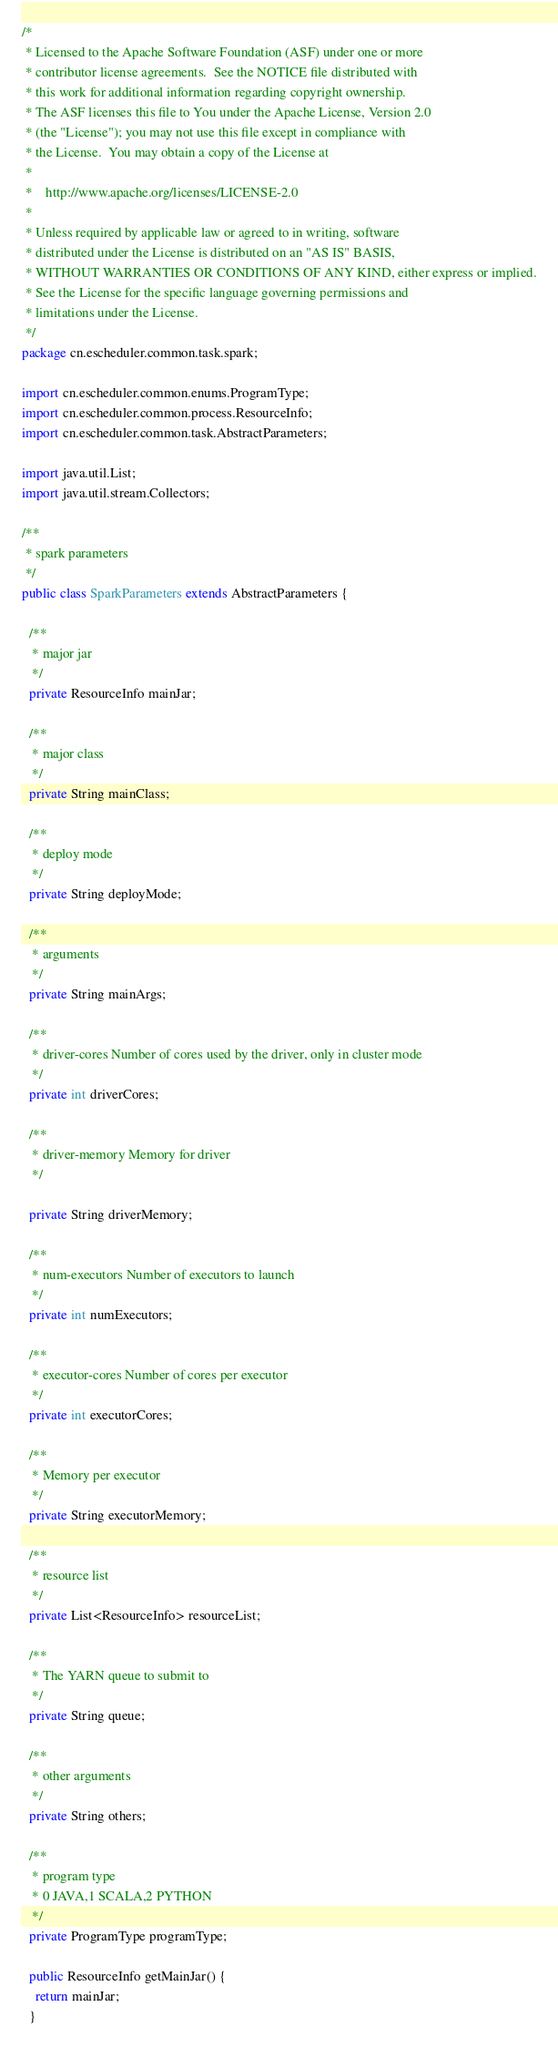Convert code to text. <code><loc_0><loc_0><loc_500><loc_500><_Java_>/*
 * Licensed to the Apache Software Foundation (ASF) under one or more
 * contributor license agreements.  See the NOTICE file distributed with
 * this work for additional information regarding copyright ownership.
 * The ASF licenses this file to You under the Apache License, Version 2.0
 * (the "License"); you may not use this file except in compliance with
 * the License.  You may obtain a copy of the License at
 *
 *    http://www.apache.org/licenses/LICENSE-2.0
 *
 * Unless required by applicable law or agreed to in writing, software
 * distributed under the License is distributed on an "AS IS" BASIS,
 * WITHOUT WARRANTIES OR CONDITIONS OF ANY KIND, either express or implied.
 * See the License for the specific language governing permissions and
 * limitations under the License.
 */
package cn.escheduler.common.task.spark;

import cn.escheduler.common.enums.ProgramType;
import cn.escheduler.common.process.ResourceInfo;
import cn.escheduler.common.task.AbstractParameters;

import java.util.List;
import java.util.stream.Collectors;

/**
 * spark parameters
 */
public class SparkParameters extends AbstractParameters {

  /**
   * major jar
   */
  private ResourceInfo mainJar;

  /**
   * major class
   */
  private String mainClass;

  /**
   * deploy mode
   */
  private String deployMode;

  /**
   * arguments
   */
  private String mainArgs;

  /**
   * driver-cores Number of cores used by the driver, only in cluster mode
   */
  private int driverCores;

  /**
   * driver-memory Memory for driver
   */

  private String driverMemory;

  /**
   * num-executors Number of executors to launch
   */
  private int numExecutors;

  /**
   * executor-cores Number of cores per executor
   */
  private int executorCores;

  /**
   * Memory per executor
   */
  private String executorMemory;

  /**
   * resource list
   */
  private List<ResourceInfo> resourceList;

  /**
   * The YARN queue to submit to
   */
  private String queue;

  /**
   * other arguments
   */
  private String others;

  /**
   * program type
   * 0 JAVA,1 SCALA,2 PYTHON
   */
  private ProgramType programType;

  public ResourceInfo getMainJar() {
    return mainJar;
  }
</code> 